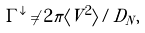Convert formula to latex. <formula><loc_0><loc_0><loc_500><loc_500>\Gamma ^ { \downarrow } \ne 2 \pi \langle V ^ { 2 } \rangle / D _ { N } ,</formula> 